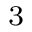Convert formula to latex. <formula><loc_0><loc_0><loc_500><loc_500>^ { 3 }</formula> 